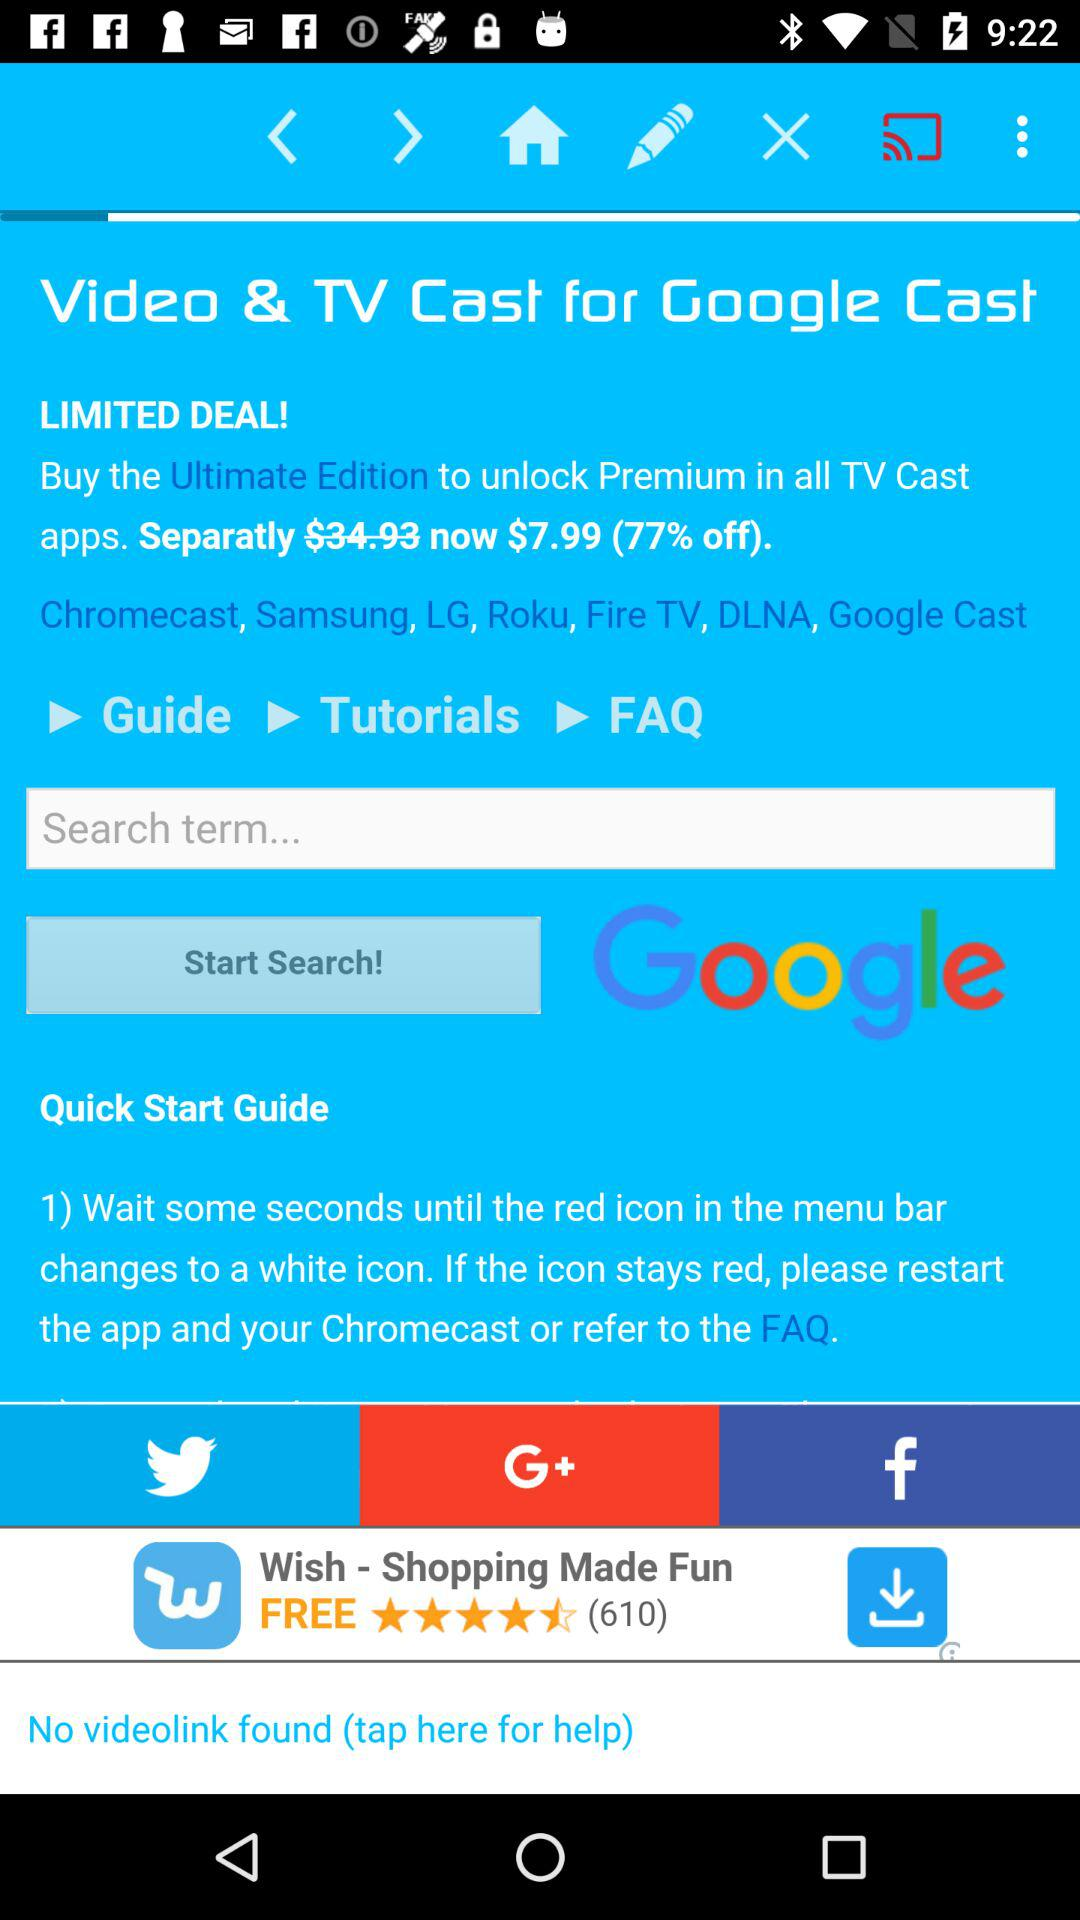Through which application can it be shared? It can be shared through "Twitter", "Google+" and "Facebook". 